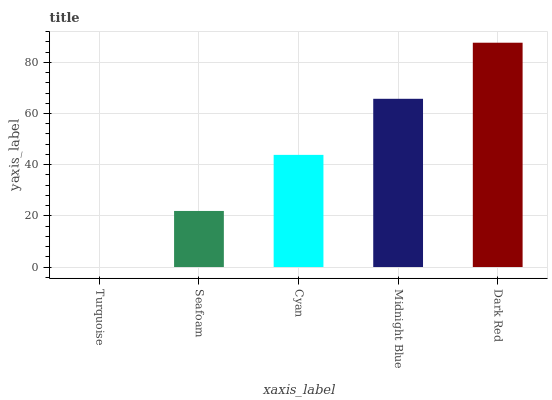Is Turquoise the minimum?
Answer yes or no. Yes. Is Dark Red the maximum?
Answer yes or no. Yes. Is Seafoam the minimum?
Answer yes or no. No. Is Seafoam the maximum?
Answer yes or no. No. Is Seafoam greater than Turquoise?
Answer yes or no. Yes. Is Turquoise less than Seafoam?
Answer yes or no. Yes. Is Turquoise greater than Seafoam?
Answer yes or no. No. Is Seafoam less than Turquoise?
Answer yes or no. No. Is Cyan the high median?
Answer yes or no. Yes. Is Cyan the low median?
Answer yes or no. Yes. Is Turquoise the high median?
Answer yes or no. No. Is Dark Red the low median?
Answer yes or no. No. 